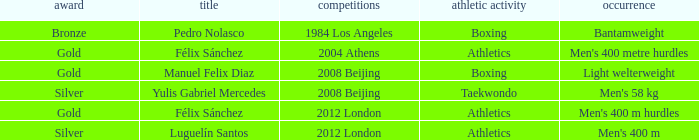Which Name had a Games of 2008 beijing, and a Medal of gold? Manuel Felix Diaz. 